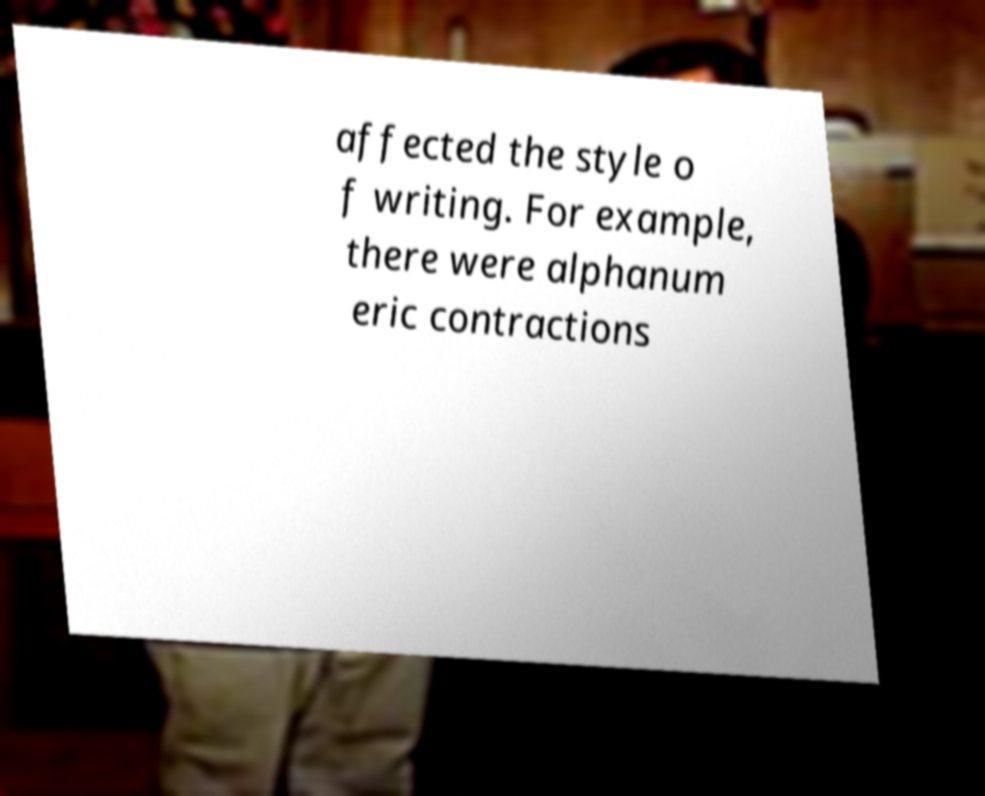Could you assist in decoding the text presented in this image and type it out clearly? affected the style o f writing. For example, there were alphanum eric contractions 